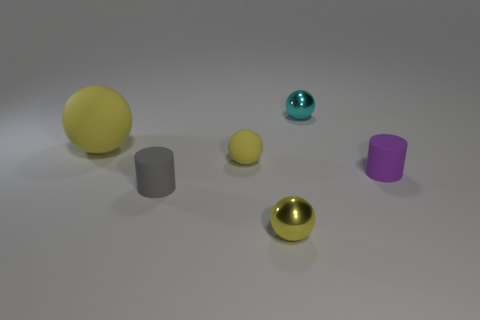Subtract all cyan cylinders. How many yellow balls are left? 3 Subtract 1 balls. How many balls are left? 3 Add 1 large green rubber cubes. How many objects exist? 7 Subtract all cylinders. How many objects are left? 4 Subtract all large gray things. Subtract all tiny matte objects. How many objects are left? 3 Add 4 small cyan things. How many small cyan things are left? 5 Add 3 shiny spheres. How many shiny spheres exist? 5 Subtract 2 yellow spheres. How many objects are left? 4 